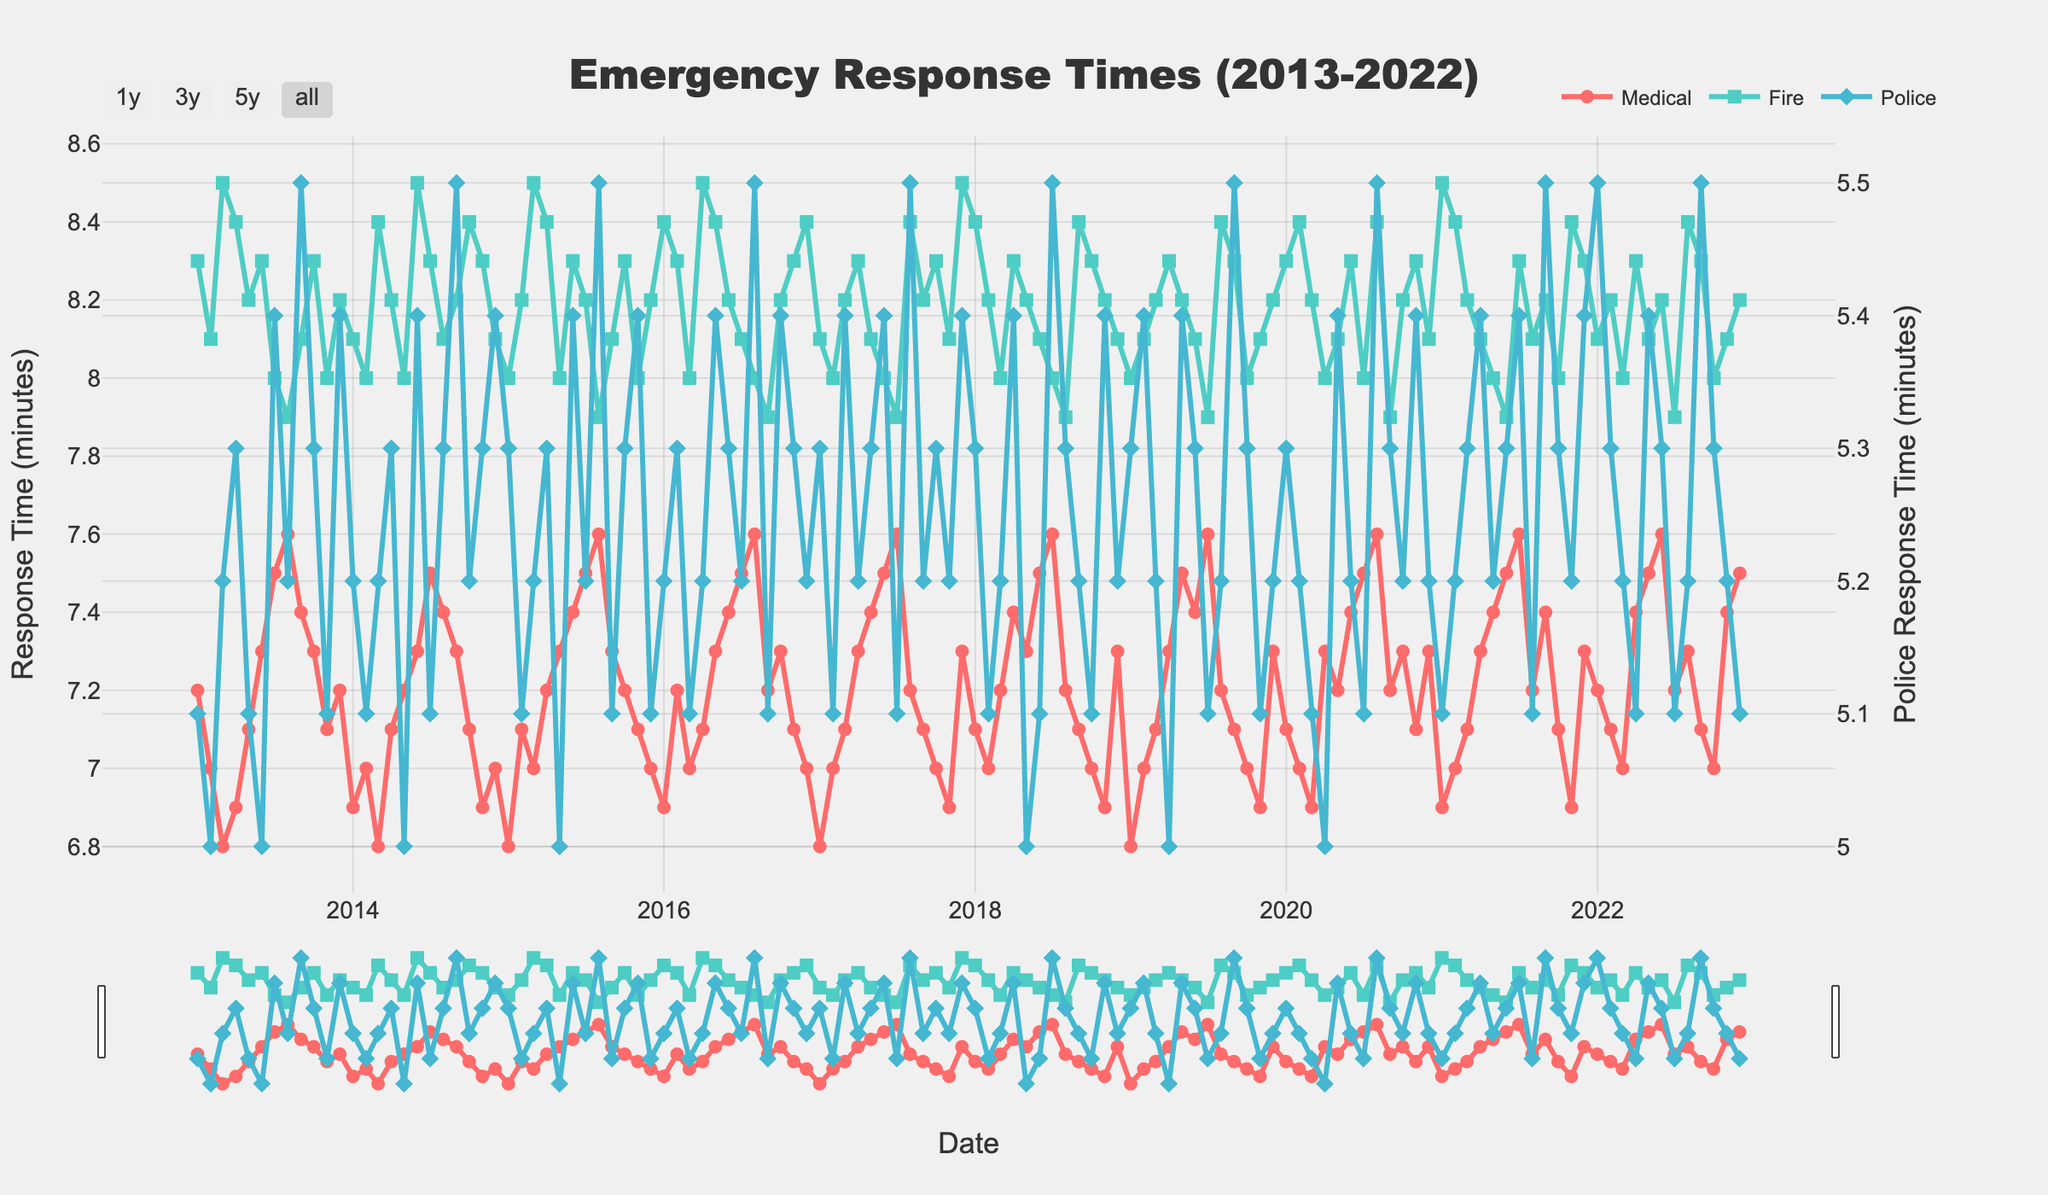How many years of data are displayed in the figure? The x-axis shows dates from January 2013 to December 2022. Counting the years from 2013 to 2022 gives a total of 10 years.
Answer: 10 years What is the title of the figure? The title is located on the top of the figure and is meant to give an overview of the data being presented.
Answer: Emergency Response Times (2013-2022) Which type of emergency response consistently has the lowest response times? From visual inspection, the Police response times have lower values compared to Medical and Fire response times across the entire time period.
Answer: Police In which month and year was the response time for Medical emergencies the highest? By examining the peak points in the Medical trace (red circles) over the x-axis range, the highest value occurs in August 2015.
Answer: August 2015 What's the average response time for Fire emergencies in July across all years? First locate all July data points in the Fire trace (green squares). Add their values (8.0 + 8.3 + 8.2 + 8.1 + 7.9 + 7.9 + 8.0 + 7.9 + 8.3 + 8.3) and divide by the number of years, which is 10. The sum is 80.9, and the average is 80.9/10.
Answer: 8.09 minutes Between which two successive years did the Police response time show the most significant decrease in January? Inspect the January data points for Police response times (blue diamonds) and observe the changes between successive years. Notice the decrease from January 2018 (5.3) to January 2019 (5.3 to 5.3).
Answer: No significant decrease What are the y-axis units for the primary and secondary y-axes? Both y-axes represent response times, with the primary y-axis for Medical and Fire (left) and the secondary y-axis for Police (right).
Answer: Response Time (minutes) for both axes How do the response times for Medical and Fire emergencies compare in April 2017? Locate April 2017 for both Medical (red circle) and Fire (green square) response times. Compare the values, which are 7.3 (Medical) and 8.3 (Fire).
Answer: Fire: higher What trend is observed in the Police response times from 2013 to 2022? Observing the overall pattern of the Police response times (blue diamonds), there seems to be a slight upward trend over the years.
Answer: Increasing trend 